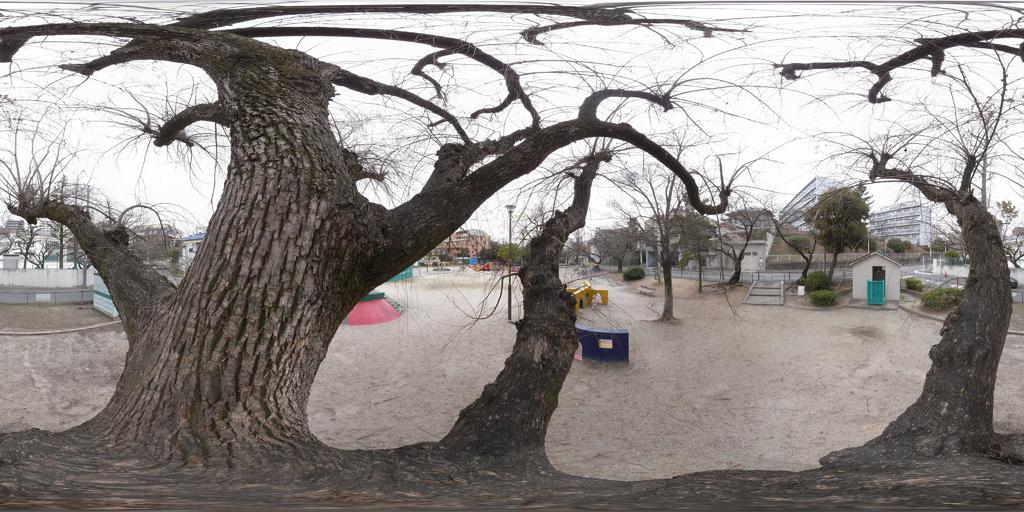Describe this image in one or two sentences. In this image I can see tree in the middle and I can see tent house and trees and buildings and poles and some objects and the sky visible in the middle. 